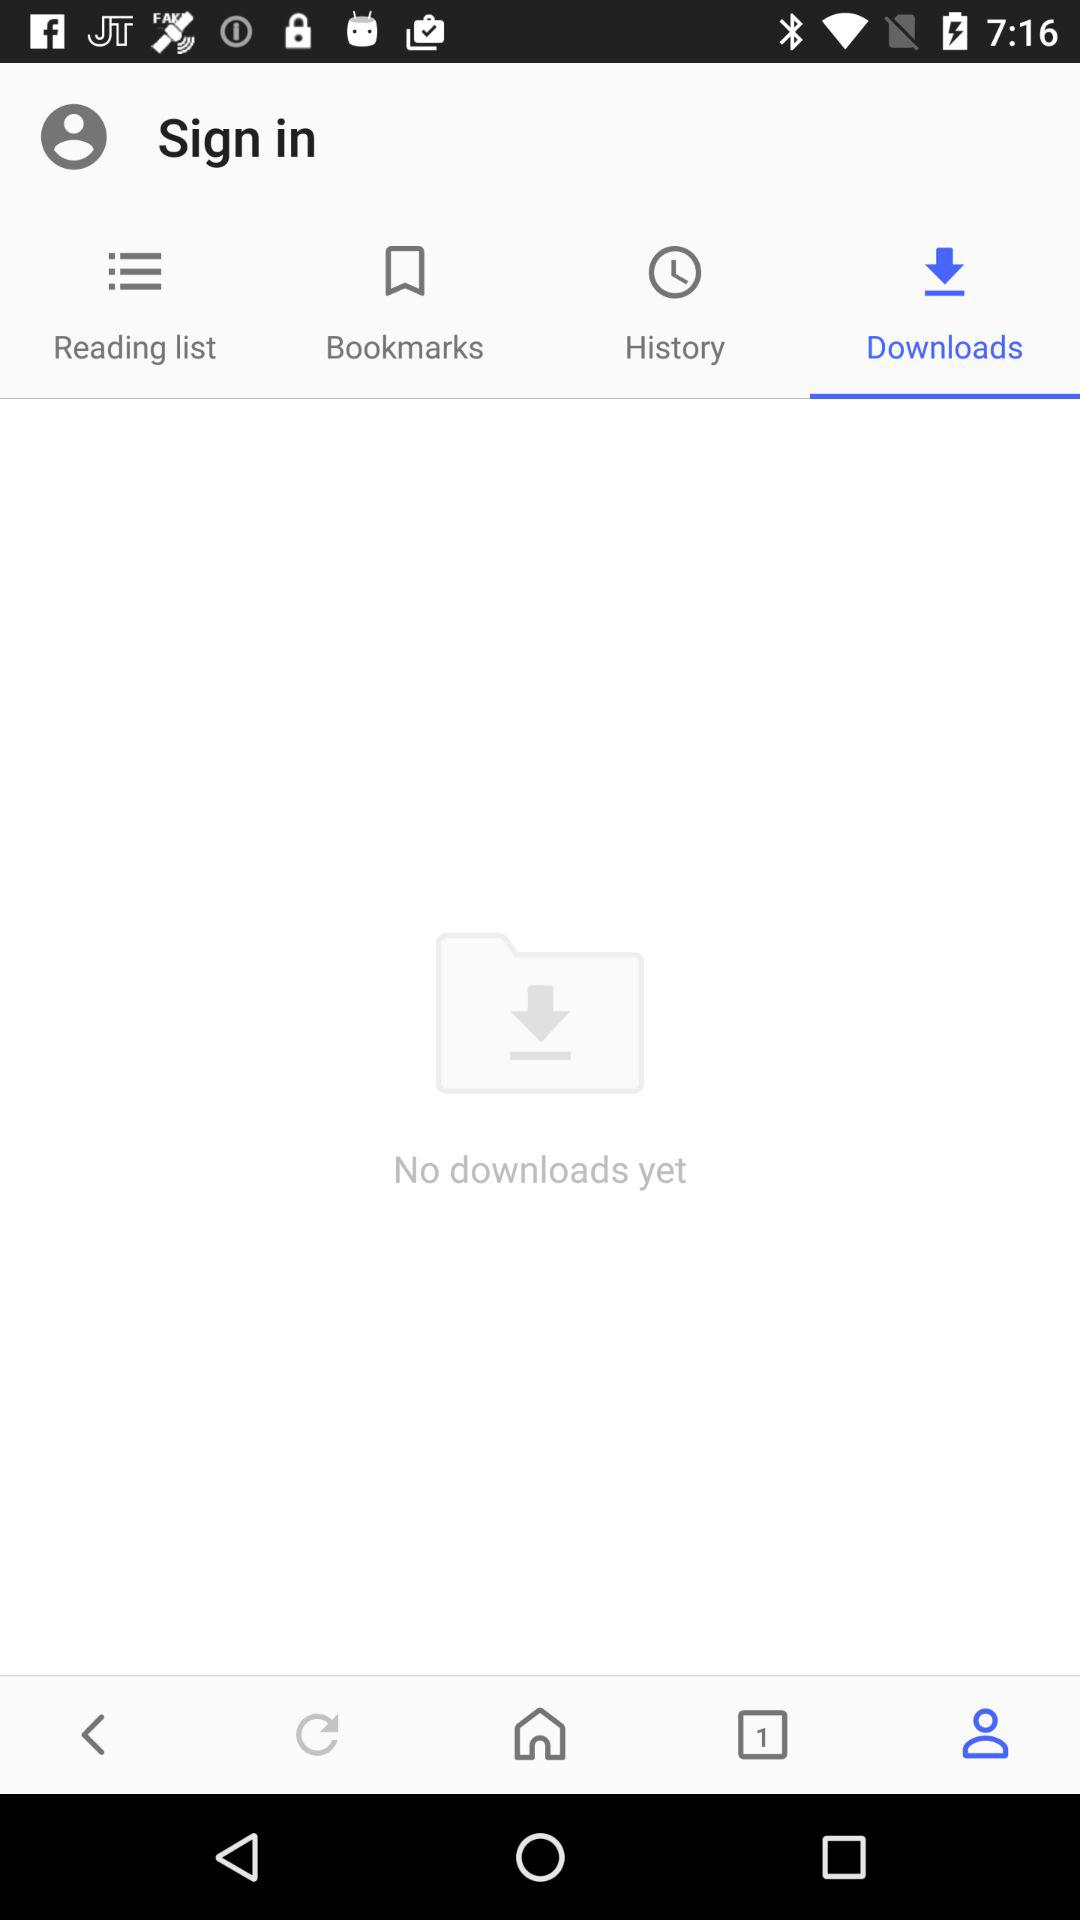How many downloads does the user have?
Answer the question using a single word or phrase. 0 